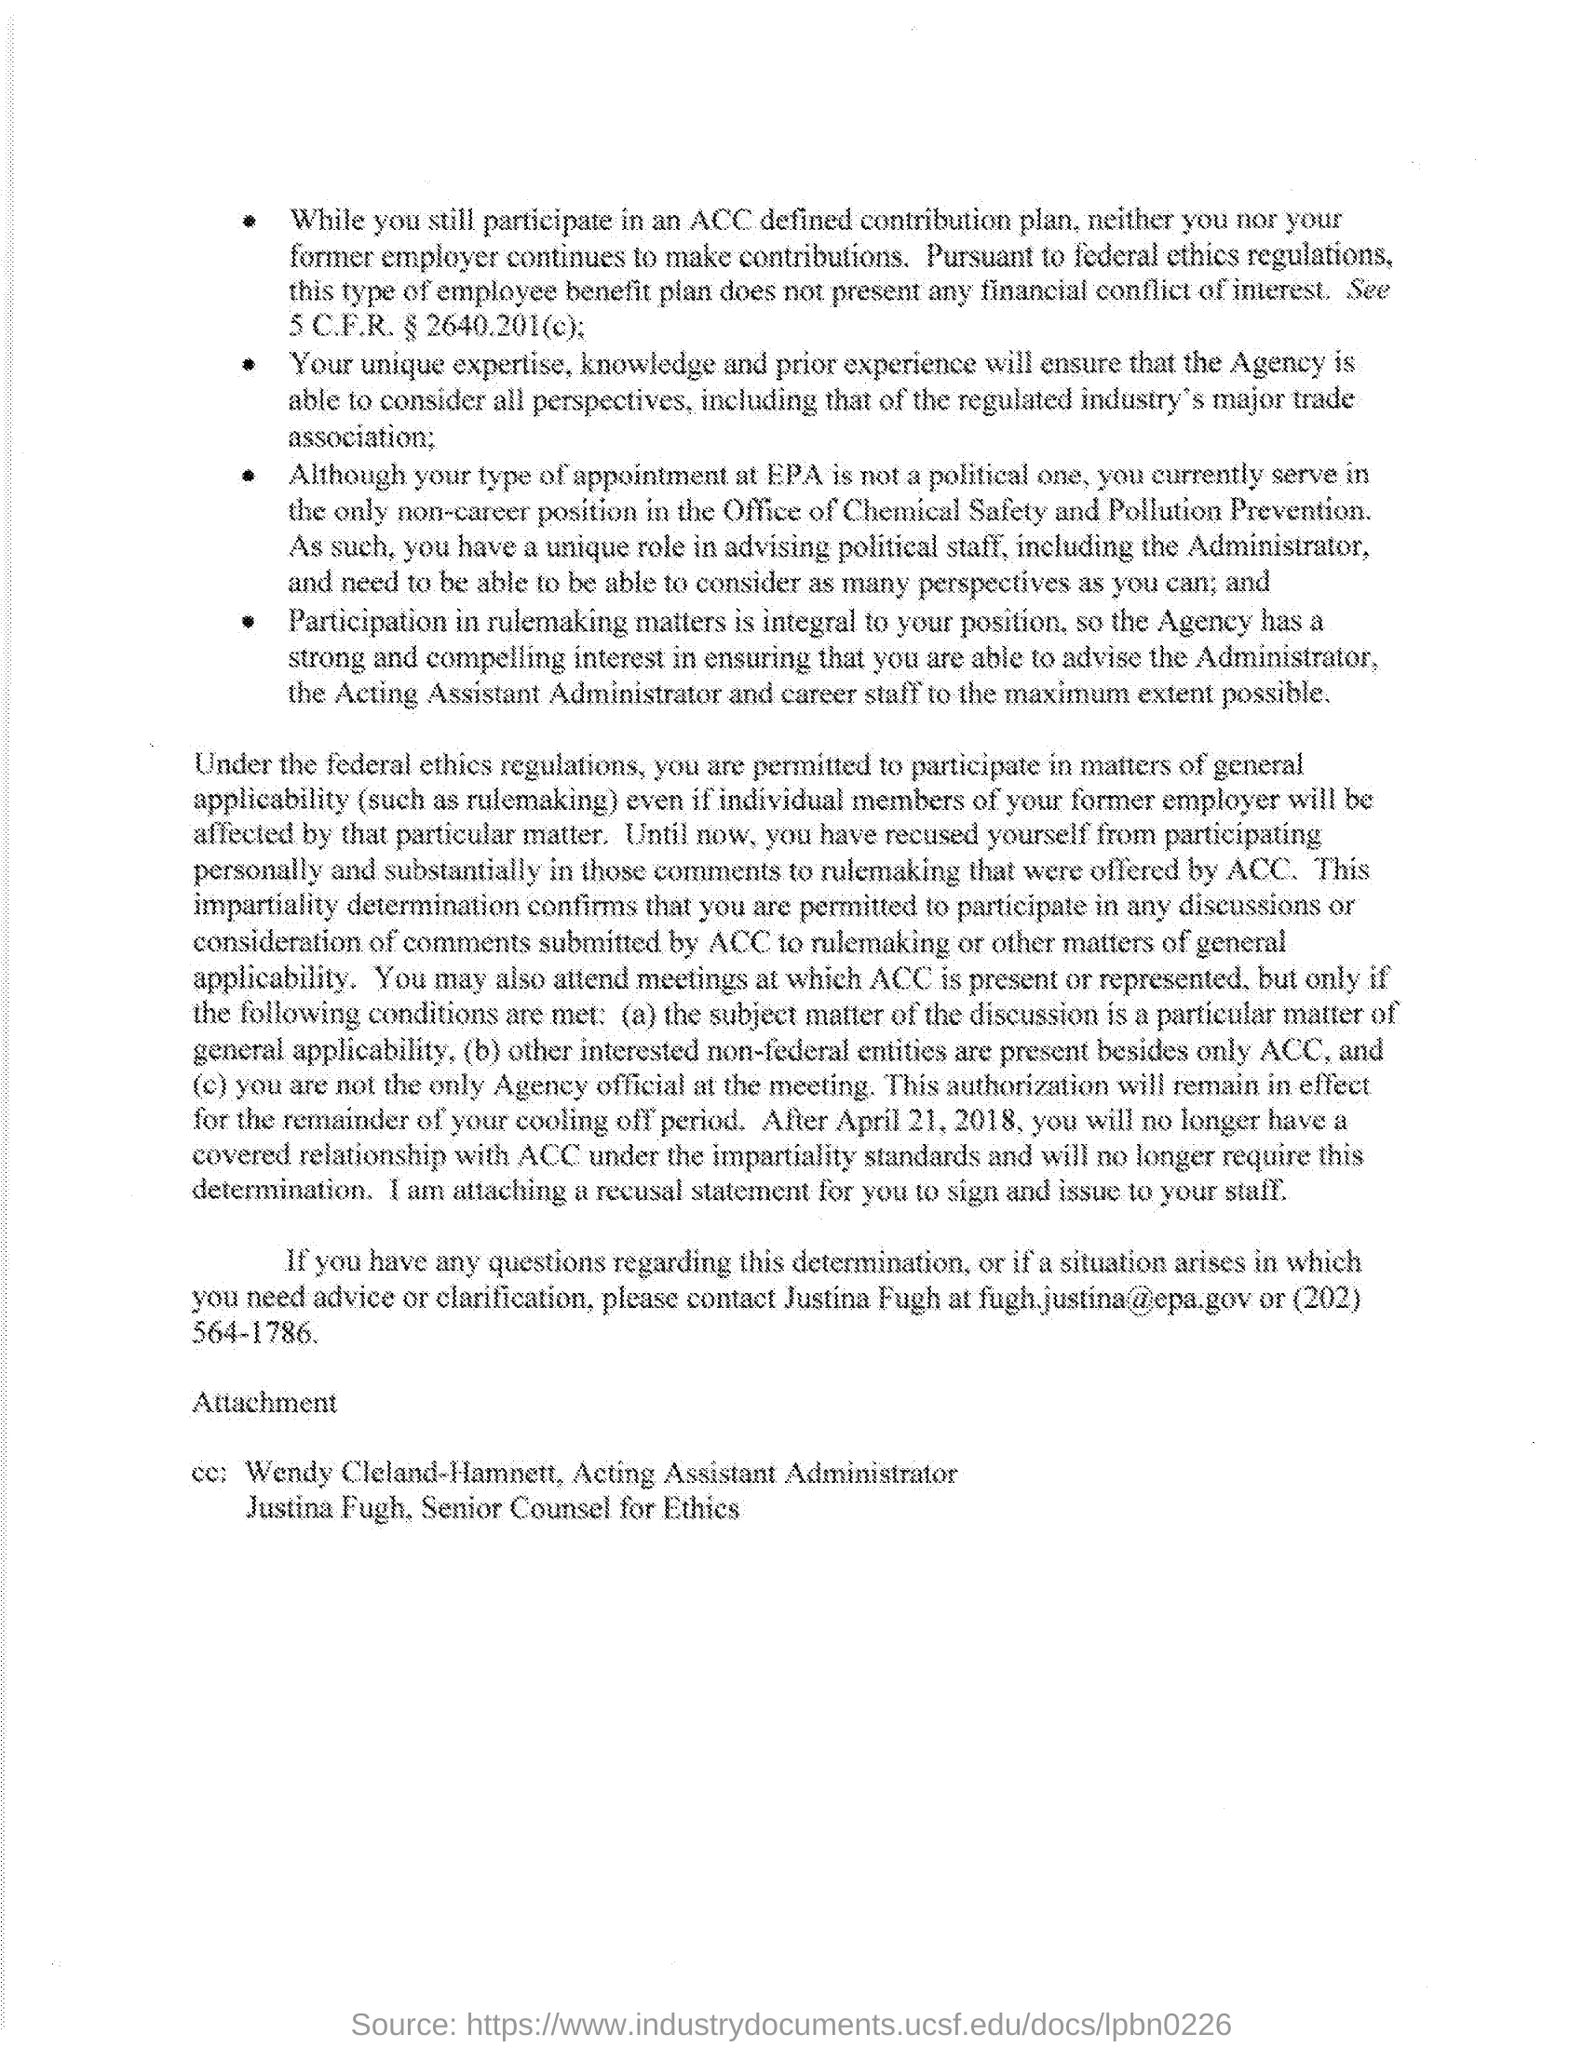What is the email id of Justina Fugh?
Your answer should be very brief. Fugh.justina@epa.gov. What is the contact no of Justina Fugh?
Give a very brief answer. (202) 564-1786. Who is the acting assistant administrator as per the document?
Keep it short and to the point. Wendy Cleland-Hamnett. What is the designation of Justina Fugh?
Ensure brevity in your answer.  Senior Counsel for Ethics. 